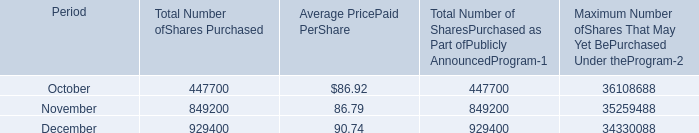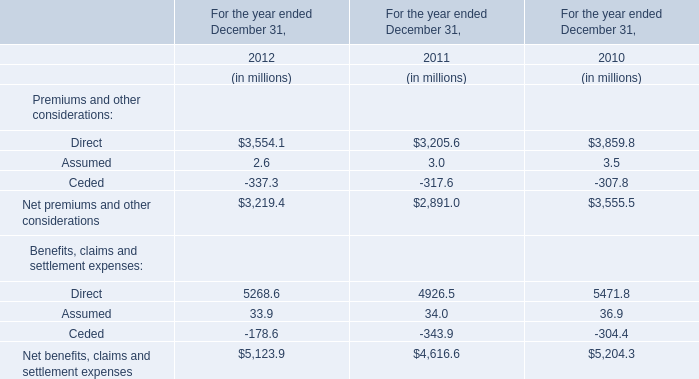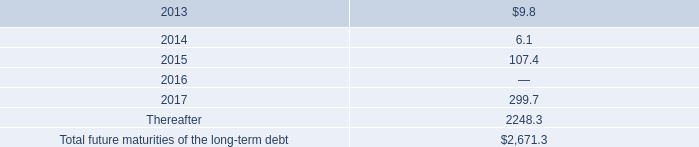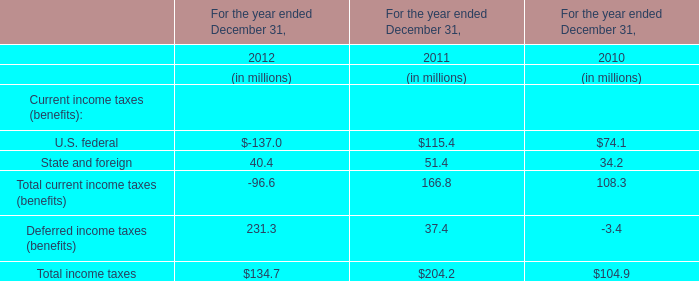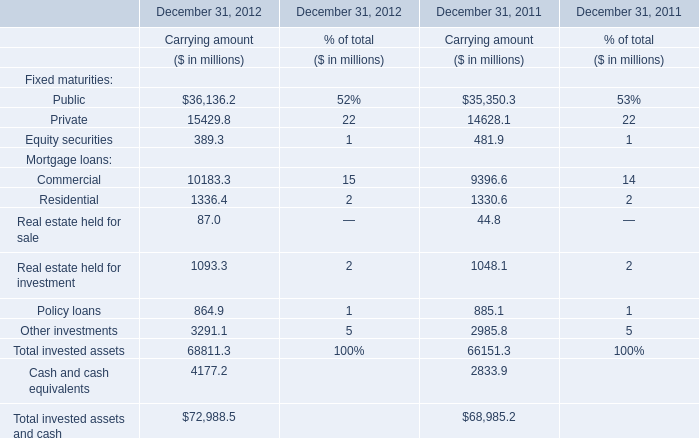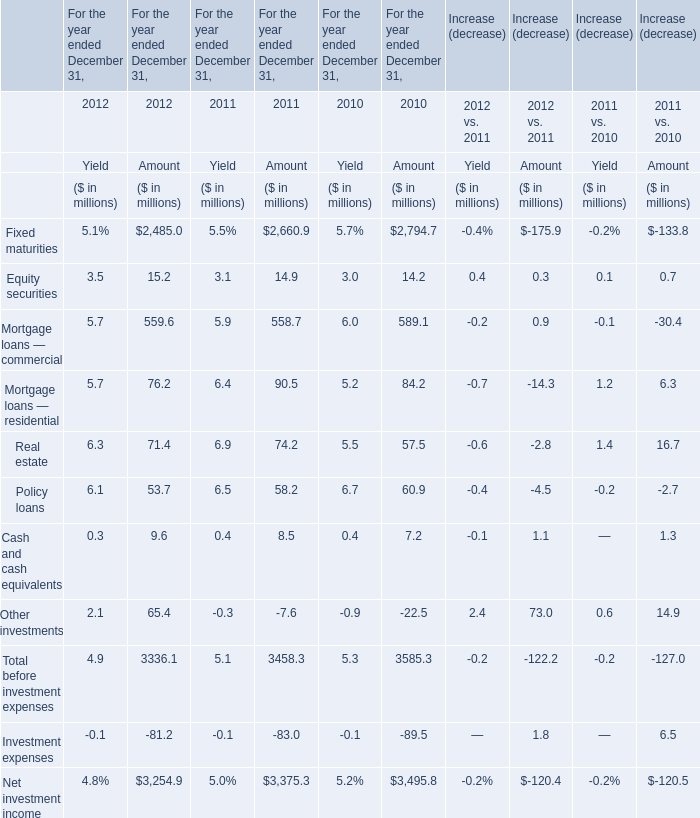In the year with the most Mortgage loans — residential, what is the growth rate of Total before investment expenses? (in %) 
Computations: ((3458.3 - 3585.3) / 3585.3)
Answer: -0.03542. 